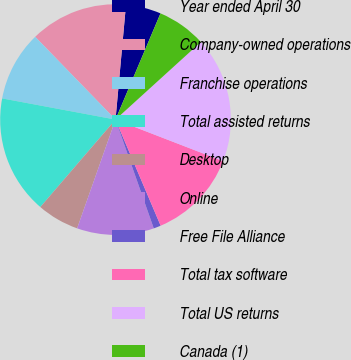Convert chart to OTSL. <chart><loc_0><loc_0><loc_500><loc_500><pie_chart><fcel>Year ended April 30<fcel>Company-owned operations<fcel>Franchise operations<fcel>Total assisted returns<fcel>Desktop<fcel>Online<fcel>Free File Alliance<fcel>Total tax software<fcel>Total US returns<fcel>Canada (1)<nl><fcel>4.93%<fcel>13.71%<fcel>9.8%<fcel>16.64%<fcel>5.9%<fcel>10.78%<fcel>1.02%<fcel>12.73%<fcel>17.61%<fcel>6.88%<nl></chart> 